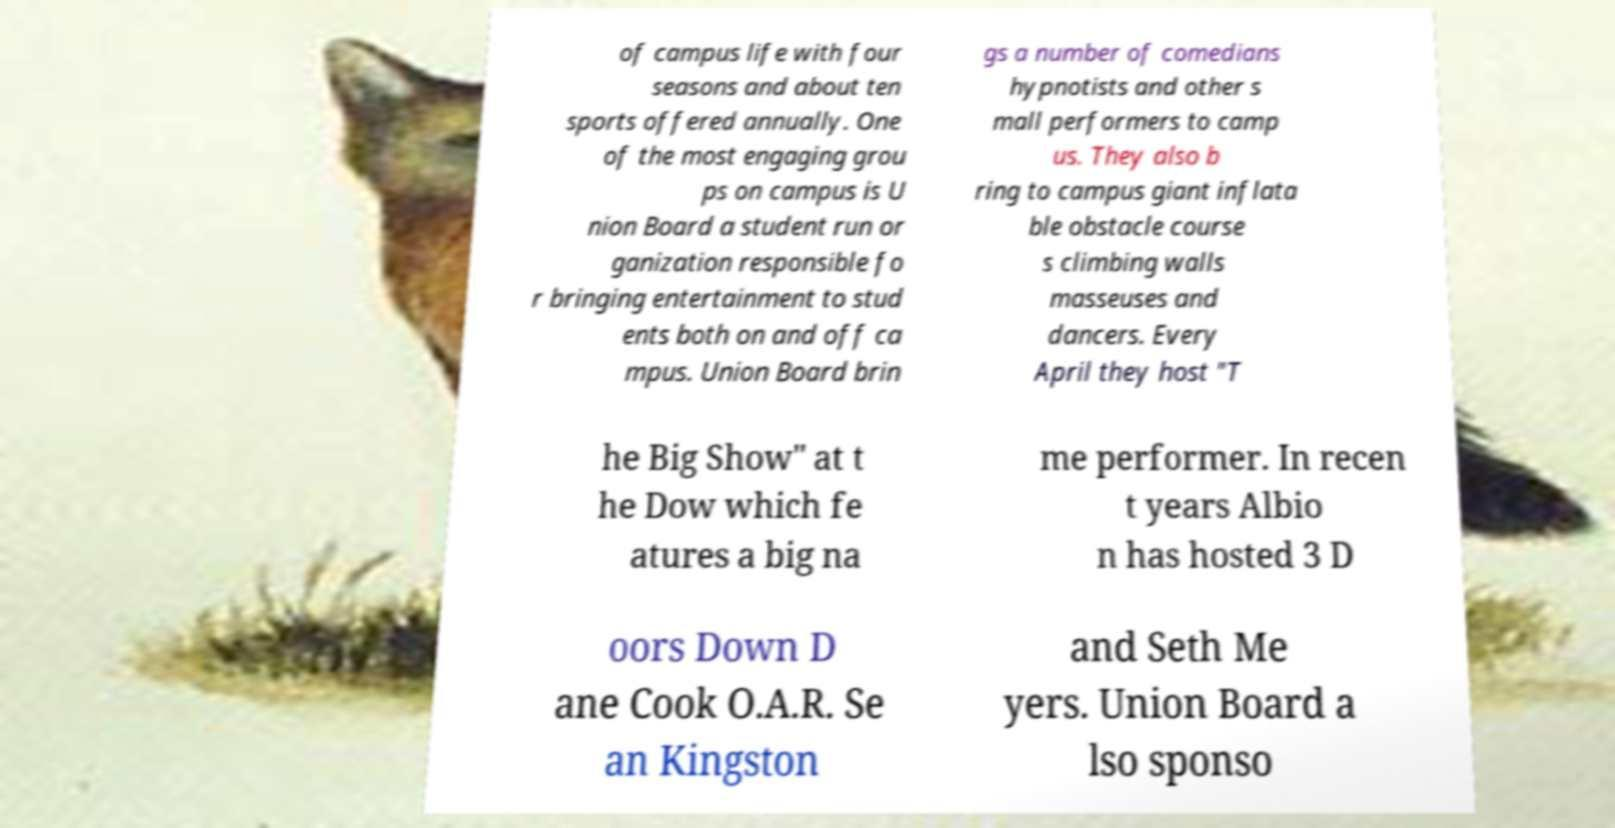What messages or text are displayed in this image? I need them in a readable, typed format. of campus life with four seasons and about ten sports offered annually. One of the most engaging grou ps on campus is U nion Board a student run or ganization responsible fo r bringing entertainment to stud ents both on and off ca mpus. Union Board brin gs a number of comedians hypnotists and other s mall performers to camp us. They also b ring to campus giant inflata ble obstacle course s climbing walls masseuses and dancers. Every April they host "T he Big Show" at t he Dow which fe atures a big na me performer. In recen t years Albio n has hosted 3 D oors Down D ane Cook O.A.R. Se an Kingston and Seth Me yers. Union Board a lso sponso 